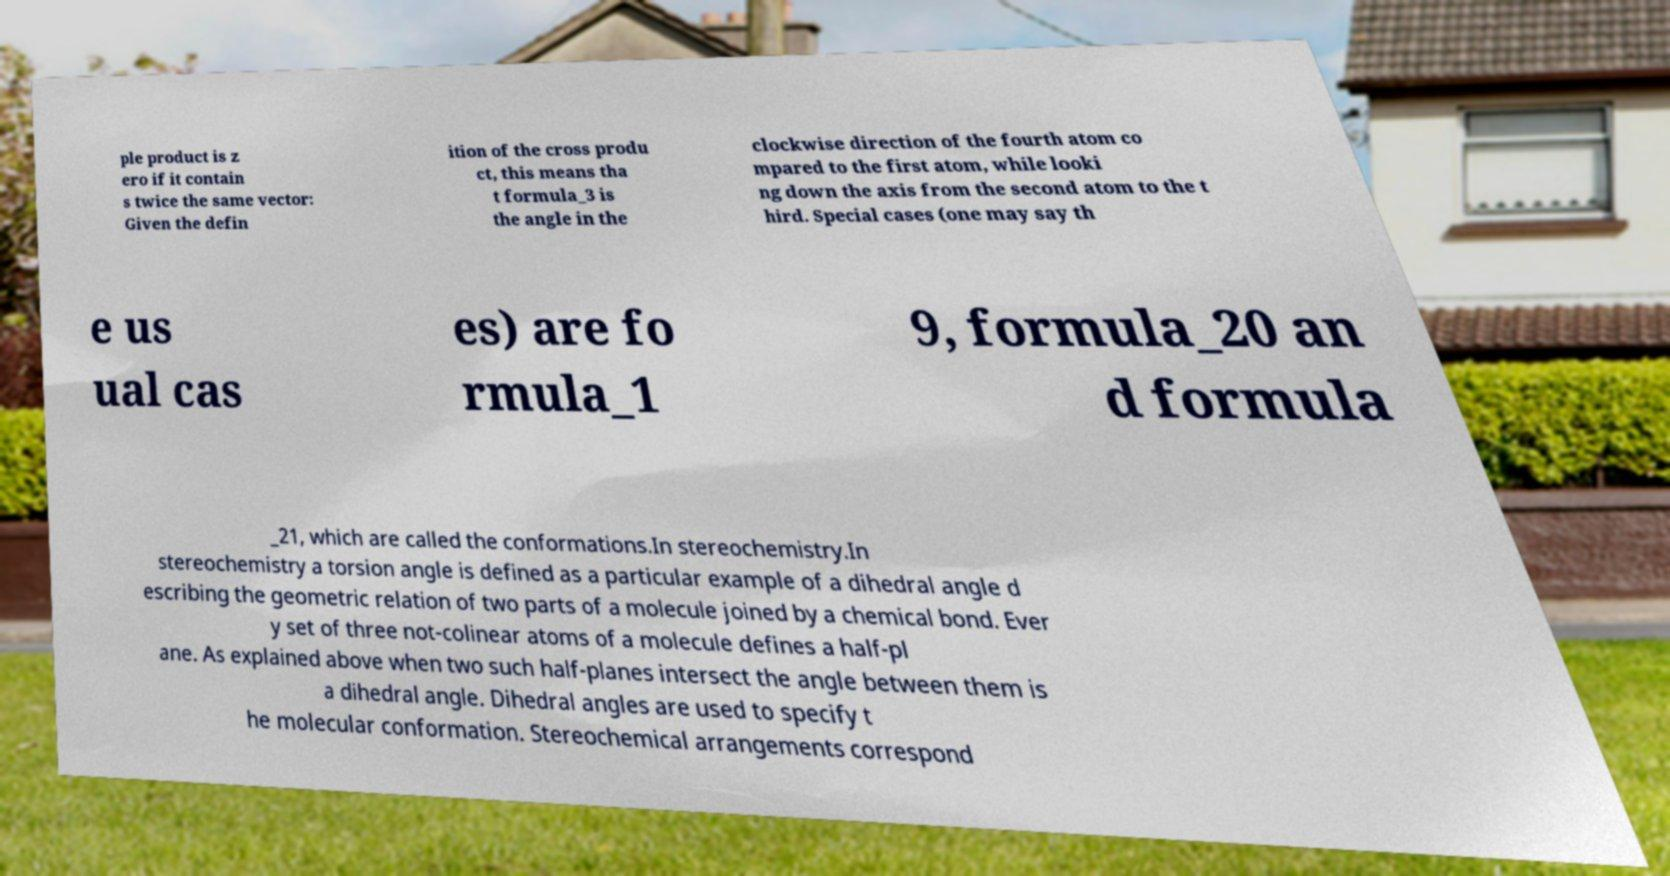I need the written content from this picture converted into text. Can you do that? ple product is z ero if it contain s twice the same vector: Given the defin ition of the cross produ ct, this means tha t formula_3 is the angle in the clockwise direction of the fourth atom co mpared to the first atom, while looki ng down the axis from the second atom to the t hird. Special cases (one may say th e us ual cas es) are fo rmula_1 9, formula_20 an d formula _21, which are called the conformations.In stereochemistry.In stereochemistry a torsion angle is defined as a particular example of a dihedral angle d escribing the geometric relation of two parts of a molecule joined by a chemical bond. Ever y set of three not-colinear atoms of a molecule defines a half-pl ane. As explained above when two such half-planes intersect the angle between them is a dihedral angle. Dihedral angles are used to specify t he molecular conformation. Stereochemical arrangements correspond 